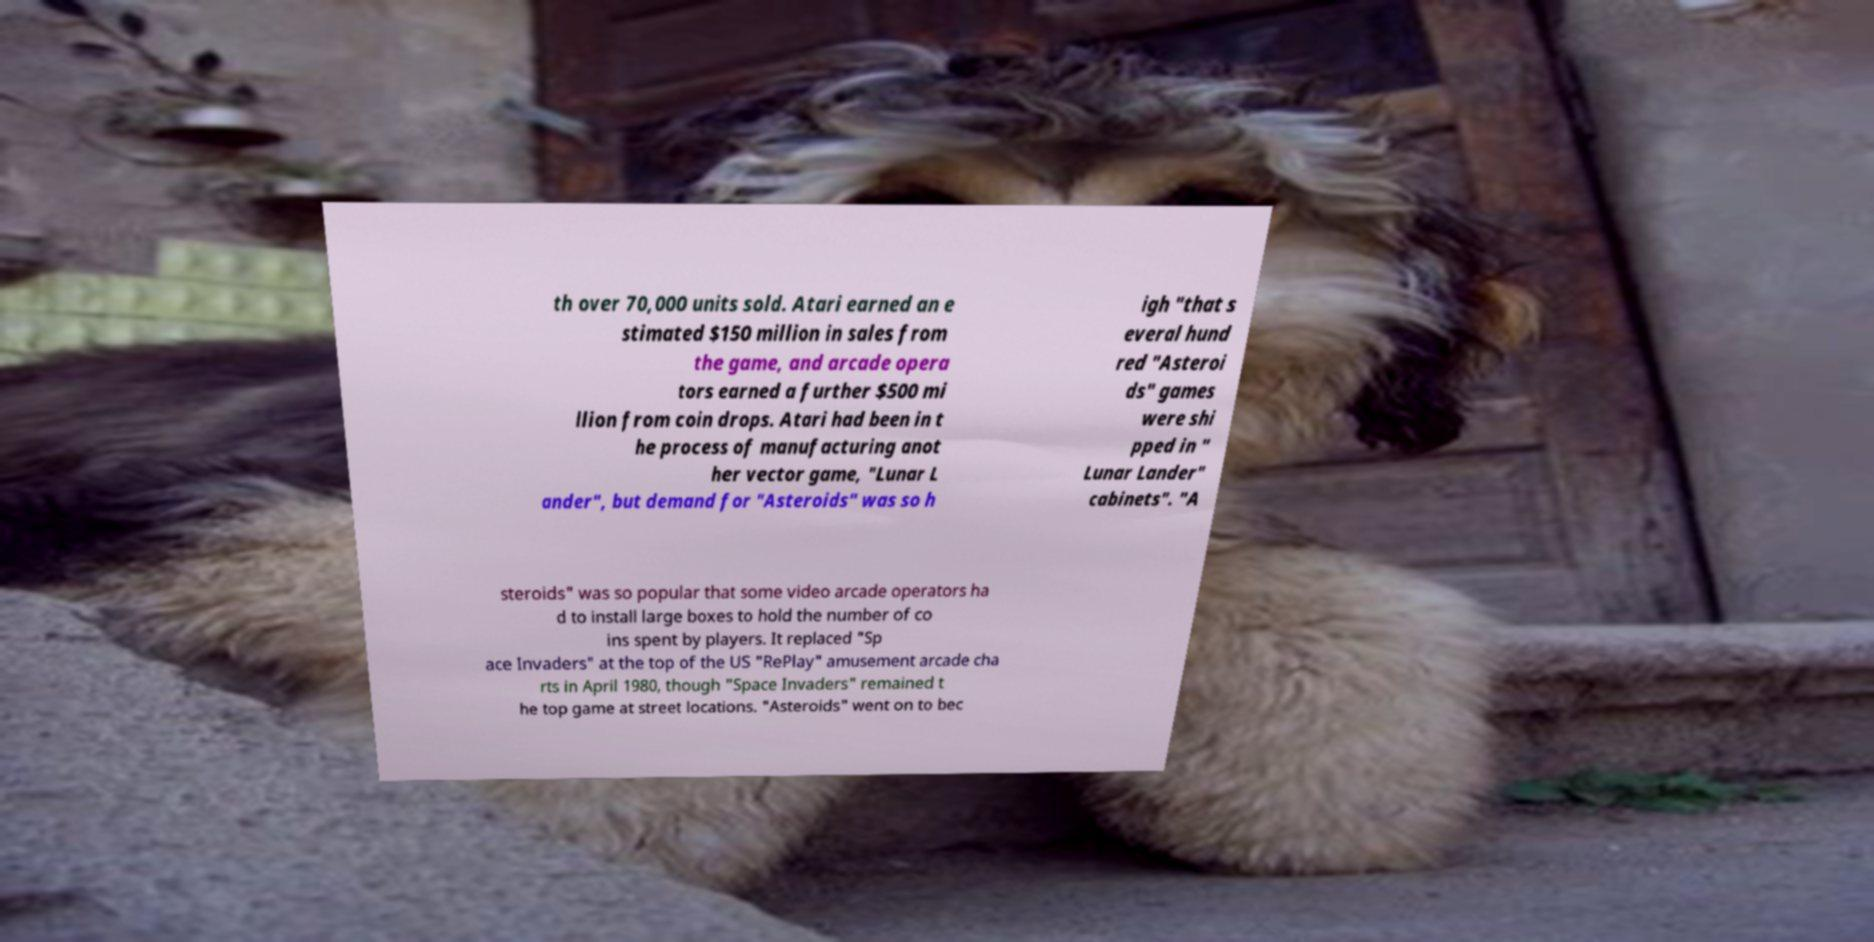Please read and relay the text visible in this image. What does it say? th over 70,000 units sold. Atari earned an e stimated $150 million in sales from the game, and arcade opera tors earned a further $500 mi llion from coin drops. Atari had been in t he process of manufacturing anot her vector game, "Lunar L ander", but demand for "Asteroids" was so h igh "that s everal hund red "Asteroi ds" games were shi pped in " Lunar Lander" cabinets". "A steroids" was so popular that some video arcade operators ha d to install large boxes to hold the number of co ins spent by players. It replaced "Sp ace Invaders" at the top of the US "RePlay" amusement arcade cha rts in April 1980, though "Space Invaders" remained t he top game at street locations. "Asteroids" went on to bec 